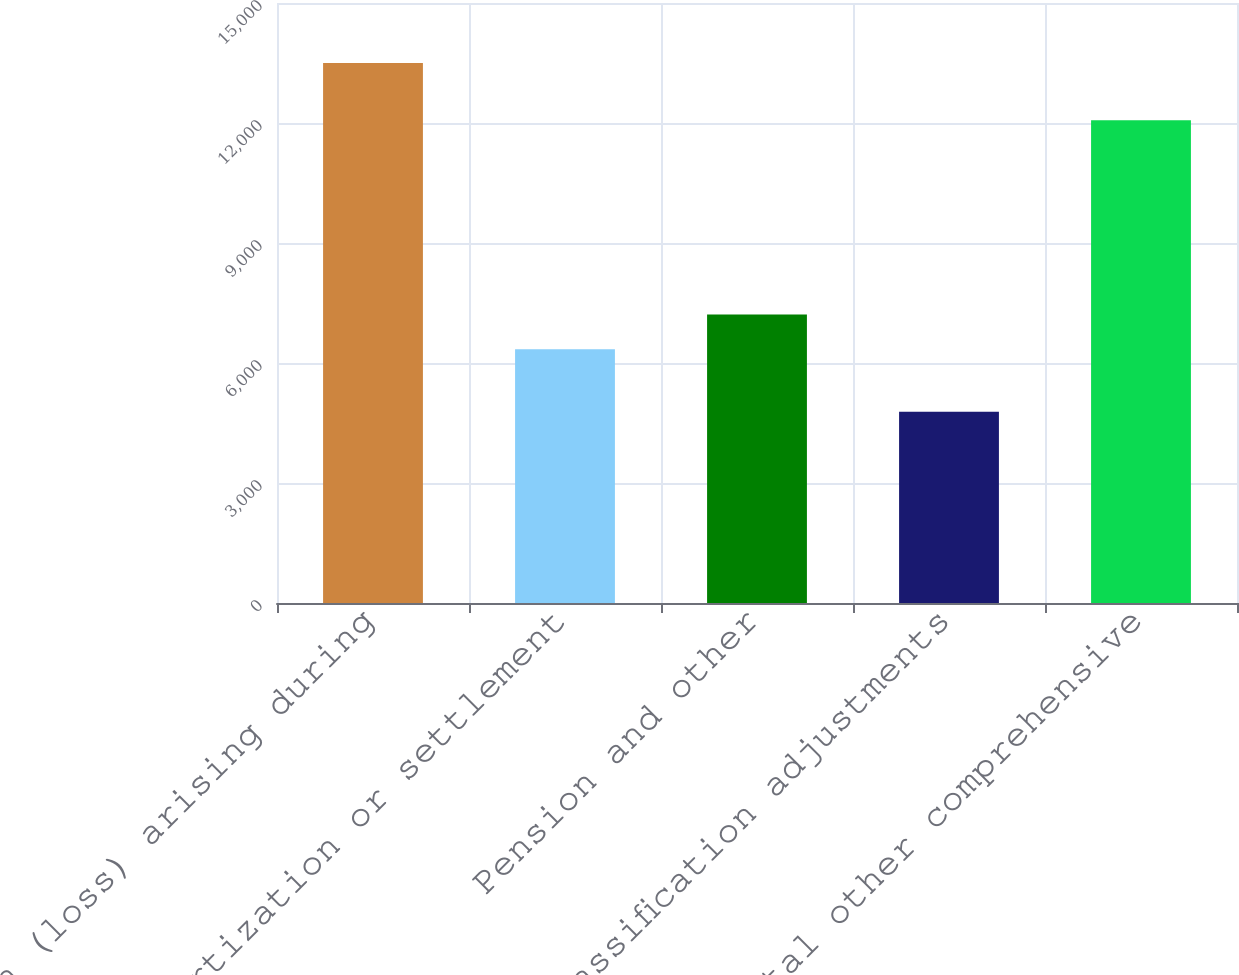Convert chart. <chart><loc_0><loc_0><loc_500><loc_500><bar_chart><fcel>Net gain (loss) arising during<fcel>Amortization or settlement<fcel>Pension and other<fcel>Reclassification adjustments<fcel>Total other comprehensive<nl><fcel>13500<fcel>6341<fcel>7213<fcel>4780<fcel>12066<nl></chart> 